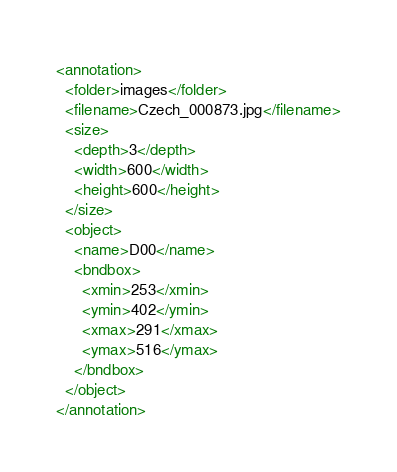Convert code to text. <code><loc_0><loc_0><loc_500><loc_500><_XML_><annotation>
  <folder>images</folder>
  <filename>Czech_000873.jpg</filename>
  <size>
    <depth>3</depth>
    <width>600</width>
    <height>600</height>
  </size>
  <object>
    <name>D00</name>
    <bndbox>
      <xmin>253</xmin>
      <ymin>402</ymin>
      <xmax>291</xmax>
      <ymax>516</ymax>
    </bndbox>
  </object>
</annotation></code> 